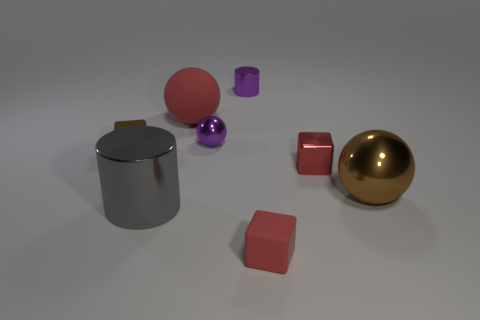Subtract all red cubes. How many cubes are left? 1 Add 2 yellow metal balls. How many objects exist? 10 Subtract all cylinders. How many objects are left? 6 Subtract 1 gray cylinders. How many objects are left? 7 Subtract all large brown metal things. Subtract all metallic blocks. How many objects are left? 5 Add 6 small red cubes. How many small red cubes are left? 8 Add 5 large brown metal objects. How many large brown metal objects exist? 6 